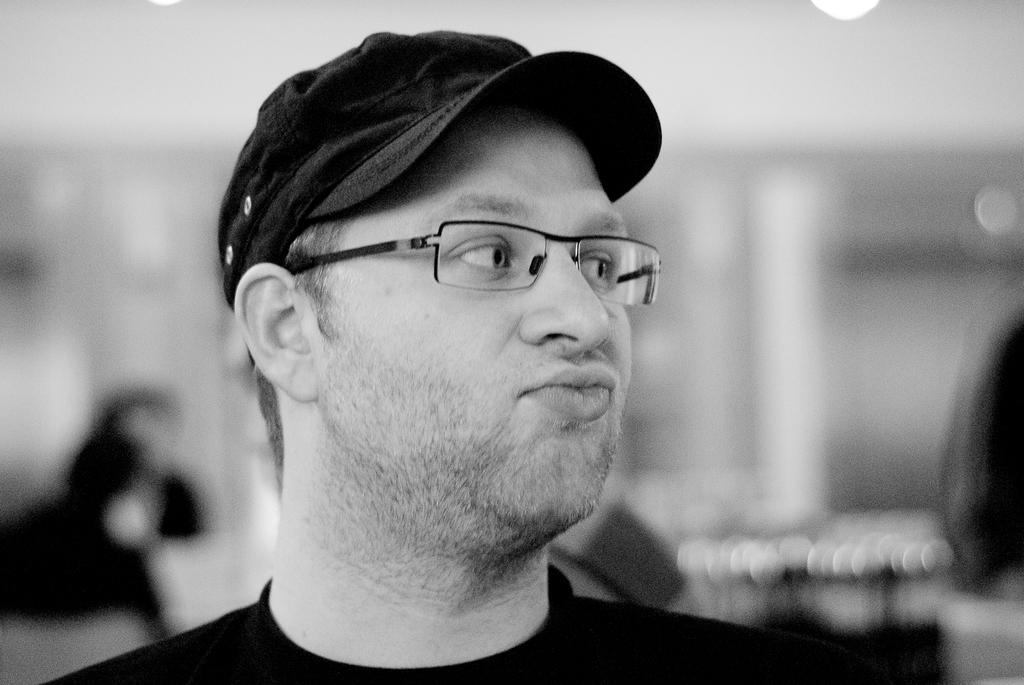What is the main subject of the image? There is a man in the image. What is the color scheme of the image? The image is black and white. Can you describe the background of the image? The background of the image is blurry. Reasoning: Let's think step by step by step in order to produce the conversation. We start by identifying the main subject of the image, which is the man. Then, we describe the color scheme of the image, which is black and white. Finally, we focus on the background of the image, noting that it is blurry. Each question is designed to elicit a specific detail about the image that is known from the provided facts. Absurd Question/Answer: What type of glue is the man using in the image? There is no glue present in the image, and the man is not using any glue. How many ears does the man have in the image? The image is black and white, and it is not possible to determine the number of ears the man has based on the provided facts. What word is the man saying in the image? There is no indication of the man speaking or saying any word in the image, as it is a black and white image with a blurry background. 